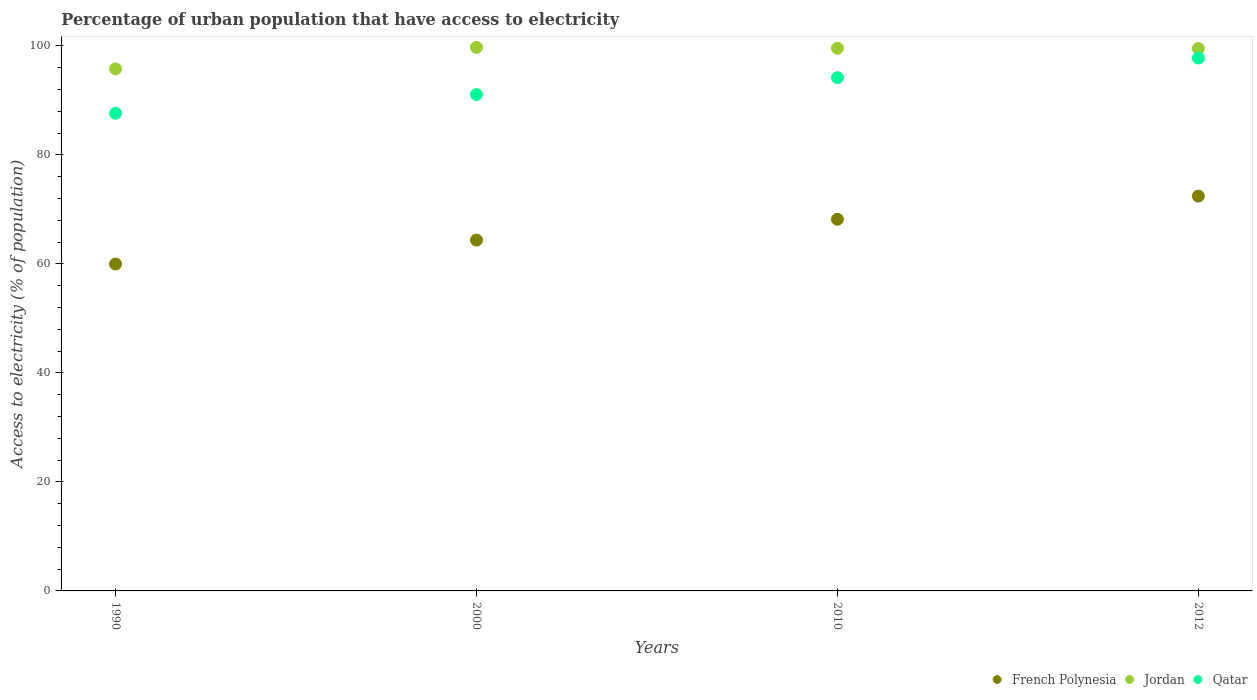Is the number of dotlines equal to the number of legend labels?
Your answer should be compact. Yes. What is the percentage of urban population that have access to electricity in French Polynesia in 1990?
Provide a succinct answer. 59.97. Across all years, what is the maximum percentage of urban population that have access to electricity in Jordan?
Ensure brevity in your answer.  99.7. Across all years, what is the minimum percentage of urban population that have access to electricity in Jordan?
Keep it short and to the point. 95.77. In which year was the percentage of urban population that have access to electricity in French Polynesia maximum?
Your answer should be compact. 2012. What is the total percentage of urban population that have access to electricity in Jordan in the graph?
Provide a short and direct response. 394.52. What is the difference between the percentage of urban population that have access to electricity in French Polynesia in 2000 and that in 2010?
Ensure brevity in your answer.  -3.82. What is the difference between the percentage of urban population that have access to electricity in French Polynesia in 1990 and the percentage of urban population that have access to electricity in Jordan in 2000?
Your answer should be very brief. -39.73. What is the average percentage of urban population that have access to electricity in French Polynesia per year?
Make the answer very short. 66.23. In the year 1990, what is the difference between the percentage of urban population that have access to electricity in French Polynesia and percentage of urban population that have access to electricity in Jordan?
Ensure brevity in your answer.  -35.8. In how many years, is the percentage of urban population that have access to electricity in Qatar greater than 28 %?
Your answer should be compact. 4. What is the ratio of the percentage of urban population that have access to electricity in French Polynesia in 2000 to that in 2012?
Make the answer very short. 0.89. Is the difference between the percentage of urban population that have access to electricity in French Polynesia in 1990 and 2012 greater than the difference between the percentage of urban population that have access to electricity in Jordan in 1990 and 2012?
Offer a very short reply. No. What is the difference between the highest and the second highest percentage of urban population that have access to electricity in Qatar?
Provide a short and direct response. 3.6. What is the difference between the highest and the lowest percentage of urban population that have access to electricity in French Polynesia?
Offer a very short reply. 12.45. In how many years, is the percentage of urban population that have access to electricity in French Polynesia greater than the average percentage of urban population that have access to electricity in French Polynesia taken over all years?
Give a very brief answer. 2. Is the sum of the percentage of urban population that have access to electricity in Qatar in 2000 and 2010 greater than the maximum percentage of urban population that have access to electricity in Jordan across all years?
Offer a terse response. Yes. Does the percentage of urban population that have access to electricity in Jordan monotonically increase over the years?
Your response must be concise. No. How many dotlines are there?
Make the answer very short. 3. How many years are there in the graph?
Your answer should be very brief. 4. Does the graph contain grids?
Make the answer very short. No. How many legend labels are there?
Keep it short and to the point. 3. How are the legend labels stacked?
Your answer should be compact. Horizontal. What is the title of the graph?
Offer a very short reply. Percentage of urban population that have access to electricity. What is the label or title of the Y-axis?
Offer a very short reply. Access to electricity (% of population). What is the Access to electricity (% of population) of French Polynesia in 1990?
Provide a succinct answer. 59.97. What is the Access to electricity (% of population) in Jordan in 1990?
Provide a succinct answer. 95.77. What is the Access to electricity (% of population) in Qatar in 1990?
Give a very brief answer. 87.62. What is the Access to electricity (% of population) in French Polynesia in 2000?
Give a very brief answer. 64.36. What is the Access to electricity (% of population) in Jordan in 2000?
Your response must be concise. 99.7. What is the Access to electricity (% of population) of Qatar in 2000?
Make the answer very short. 91.05. What is the Access to electricity (% of population) in French Polynesia in 2010?
Offer a terse response. 68.18. What is the Access to electricity (% of population) in Jordan in 2010?
Make the answer very short. 99.55. What is the Access to electricity (% of population) of Qatar in 2010?
Keep it short and to the point. 94.15. What is the Access to electricity (% of population) in French Polynesia in 2012?
Your response must be concise. 72.42. What is the Access to electricity (% of population) of Jordan in 2012?
Provide a succinct answer. 99.5. What is the Access to electricity (% of population) of Qatar in 2012?
Provide a succinct answer. 97.75. Across all years, what is the maximum Access to electricity (% of population) of French Polynesia?
Offer a terse response. 72.42. Across all years, what is the maximum Access to electricity (% of population) in Jordan?
Provide a succinct answer. 99.7. Across all years, what is the maximum Access to electricity (% of population) in Qatar?
Your answer should be compact. 97.75. Across all years, what is the minimum Access to electricity (% of population) in French Polynesia?
Keep it short and to the point. 59.97. Across all years, what is the minimum Access to electricity (% of population) in Jordan?
Offer a terse response. 95.77. Across all years, what is the minimum Access to electricity (% of population) of Qatar?
Make the answer very short. 87.62. What is the total Access to electricity (% of population) in French Polynesia in the graph?
Your response must be concise. 264.92. What is the total Access to electricity (% of population) in Jordan in the graph?
Ensure brevity in your answer.  394.52. What is the total Access to electricity (% of population) of Qatar in the graph?
Provide a short and direct response. 370.58. What is the difference between the Access to electricity (% of population) of French Polynesia in 1990 and that in 2000?
Keep it short and to the point. -4.39. What is the difference between the Access to electricity (% of population) of Jordan in 1990 and that in 2000?
Your response must be concise. -3.94. What is the difference between the Access to electricity (% of population) in Qatar in 1990 and that in 2000?
Keep it short and to the point. -3.43. What is the difference between the Access to electricity (% of population) of French Polynesia in 1990 and that in 2010?
Ensure brevity in your answer.  -8.21. What is the difference between the Access to electricity (% of population) of Jordan in 1990 and that in 2010?
Keep it short and to the point. -3.78. What is the difference between the Access to electricity (% of population) in Qatar in 1990 and that in 2010?
Ensure brevity in your answer.  -6.54. What is the difference between the Access to electricity (% of population) of French Polynesia in 1990 and that in 2012?
Ensure brevity in your answer.  -12.45. What is the difference between the Access to electricity (% of population) of Jordan in 1990 and that in 2012?
Keep it short and to the point. -3.73. What is the difference between the Access to electricity (% of population) in Qatar in 1990 and that in 2012?
Provide a short and direct response. -10.13. What is the difference between the Access to electricity (% of population) in French Polynesia in 2000 and that in 2010?
Give a very brief answer. -3.82. What is the difference between the Access to electricity (% of population) in Jordan in 2000 and that in 2010?
Offer a terse response. 0.15. What is the difference between the Access to electricity (% of population) of Qatar in 2000 and that in 2010?
Give a very brief answer. -3.1. What is the difference between the Access to electricity (% of population) of French Polynesia in 2000 and that in 2012?
Keep it short and to the point. -8.06. What is the difference between the Access to electricity (% of population) of Jordan in 2000 and that in 2012?
Provide a short and direct response. 0.2. What is the difference between the Access to electricity (% of population) in Qatar in 2000 and that in 2012?
Offer a very short reply. -6.7. What is the difference between the Access to electricity (% of population) of French Polynesia in 2010 and that in 2012?
Ensure brevity in your answer.  -4.25. What is the difference between the Access to electricity (% of population) in Jordan in 2010 and that in 2012?
Your response must be concise. 0.05. What is the difference between the Access to electricity (% of population) of Qatar in 2010 and that in 2012?
Give a very brief answer. -3.6. What is the difference between the Access to electricity (% of population) of French Polynesia in 1990 and the Access to electricity (% of population) of Jordan in 2000?
Keep it short and to the point. -39.73. What is the difference between the Access to electricity (% of population) in French Polynesia in 1990 and the Access to electricity (% of population) in Qatar in 2000?
Your response must be concise. -31.08. What is the difference between the Access to electricity (% of population) in Jordan in 1990 and the Access to electricity (% of population) in Qatar in 2000?
Provide a short and direct response. 4.72. What is the difference between the Access to electricity (% of population) in French Polynesia in 1990 and the Access to electricity (% of population) in Jordan in 2010?
Your answer should be very brief. -39.58. What is the difference between the Access to electricity (% of population) in French Polynesia in 1990 and the Access to electricity (% of population) in Qatar in 2010?
Give a very brief answer. -34.19. What is the difference between the Access to electricity (% of population) of Jordan in 1990 and the Access to electricity (% of population) of Qatar in 2010?
Your response must be concise. 1.61. What is the difference between the Access to electricity (% of population) in French Polynesia in 1990 and the Access to electricity (% of population) in Jordan in 2012?
Your answer should be compact. -39.53. What is the difference between the Access to electricity (% of population) in French Polynesia in 1990 and the Access to electricity (% of population) in Qatar in 2012?
Your answer should be compact. -37.78. What is the difference between the Access to electricity (% of population) of Jordan in 1990 and the Access to electricity (% of population) of Qatar in 2012?
Offer a very short reply. -1.98. What is the difference between the Access to electricity (% of population) in French Polynesia in 2000 and the Access to electricity (% of population) in Jordan in 2010?
Offer a terse response. -35.19. What is the difference between the Access to electricity (% of population) of French Polynesia in 2000 and the Access to electricity (% of population) of Qatar in 2010?
Your answer should be compact. -29.8. What is the difference between the Access to electricity (% of population) in Jordan in 2000 and the Access to electricity (% of population) in Qatar in 2010?
Keep it short and to the point. 5.55. What is the difference between the Access to electricity (% of population) in French Polynesia in 2000 and the Access to electricity (% of population) in Jordan in 2012?
Your answer should be very brief. -35.14. What is the difference between the Access to electricity (% of population) of French Polynesia in 2000 and the Access to electricity (% of population) of Qatar in 2012?
Your response must be concise. -33.4. What is the difference between the Access to electricity (% of population) in Jordan in 2000 and the Access to electricity (% of population) in Qatar in 2012?
Provide a short and direct response. 1.95. What is the difference between the Access to electricity (% of population) in French Polynesia in 2010 and the Access to electricity (% of population) in Jordan in 2012?
Provide a succinct answer. -31.32. What is the difference between the Access to electricity (% of population) in French Polynesia in 2010 and the Access to electricity (% of population) in Qatar in 2012?
Your answer should be very brief. -29.58. What is the difference between the Access to electricity (% of population) in Jordan in 2010 and the Access to electricity (% of population) in Qatar in 2012?
Offer a very short reply. 1.8. What is the average Access to electricity (% of population) of French Polynesia per year?
Give a very brief answer. 66.23. What is the average Access to electricity (% of population) of Jordan per year?
Provide a short and direct response. 98.63. What is the average Access to electricity (% of population) of Qatar per year?
Ensure brevity in your answer.  92.64. In the year 1990, what is the difference between the Access to electricity (% of population) in French Polynesia and Access to electricity (% of population) in Jordan?
Offer a terse response. -35.8. In the year 1990, what is the difference between the Access to electricity (% of population) in French Polynesia and Access to electricity (% of population) in Qatar?
Provide a succinct answer. -27.65. In the year 1990, what is the difference between the Access to electricity (% of population) of Jordan and Access to electricity (% of population) of Qatar?
Your response must be concise. 8.15. In the year 2000, what is the difference between the Access to electricity (% of population) of French Polynesia and Access to electricity (% of population) of Jordan?
Provide a short and direct response. -35.35. In the year 2000, what is the difference between the Access to electricity (% of population) of French Polynesia and Access to electricity (% of population) of Qatar?
Ensure brevity in your answer.  -26.69. In the year 2000, what is the difference between the Access to electricity (% of population) in Jordan and Access to electricity (% of population) in Qatar?
Make the answer very short. 8.65. In the year 2010, what is the difference between the Access to electricity (% of population) in French Polynesia and Access to electricity (% of population) in Jordan?
Offer a very short reply. -31.37. In the year 2010, what is the difference between the Access to electricity (% of population) of French Polynesia and Access to electricity (% of population) of Qatar?
Give a very brief answer. -25.98. In the year 2010, what is the difference between the Access to electricity (% of population) of Jordan and Access to electricity (% of population) of Qatar?
Keep it short and to the point. 5.39. In the year 2012, what is the difference between the Access to electricity (% of population) in French Polynesia and Access to electricity (% of population) in Jordan?
Provide a short and direct response. -27.08. In the year 2012, what is the difference between the Access to electricity (% of population) in French Polynesia and Access to electricity (% of population) in Qatar?
Your answer should be compact. -25.33. In the year 2012, what is the difference between the Access to electricity (% of population) of Jordan and Access to electricity (% of population) of Qatar?
Your answer should be very brief. 1.75. What is the ratio of the Access to electricity (% of population) of French Polynesia in 1990 to that in 2000?
Make the answer very short. 0.93. What is the ratio of the Access to electricity (% of population) in Jordan in 1990 to that in 2000?
Ensure brevity in your answer.  0.96. What is the ratio of the Access to electricity (% of population) of Qatar in 1990 to that in 2000?
Ensure brevity in your answer.  0.96. What is the ratio of the Access to electricity (% of population) in French Polynesia in 1990 to that in 2010?
Your answer should be very brief. 0.88. What is the ratio of the Access to electricity (% of population) of Qatar in 1990 to that in 2010?
Make the answer very short. 0.93. What is the ratio of the Access to electricity (% of population) in French Polynesia in 1990 to that in 2012?
Offer a very short reply. 0.83. What is the ratio of the Access to electricity (% of population) of Jordan in 1990 to that in 2012?
Offer a very short reply. 0.96. What is the ratio of the Access to electricity (% of population) of Qatar in 1990 to that in 2012?
Offer a very short reply. 0.9. What is the ratio of the Access to electricity (% of population) in French Polynesia in 2000 to that in 2010?
Ensure brevity in your answer.  0.94. What is the ratio of the Access to electricity (% of population) of Jordan in 2000 to that in 2010?
Your answer should be compact. 1. What is the ratio of the Access to electricity (% of population) of Qatar in 2000 to that in 2010?
Your answer should be very brief. 0.97. What is the ratio of the Access to electricity (% of population) in French Polynesia in 2000 to that in 2012?
Your answer should be compact. 0.89. What is the ratio of the Access to electricity (% of population) of Jordan in 2000 to that in 2012?
Keep it short and to the point. 1. What is the ratio of the Access to electricity (% of population) of Qatar in 2000 to that in 2012?
Your response must be concise. 0.93. What is the ratio of the Access to electricity (% of population) of French Polynesia in 2010 to that in 2012?
Give a very brief answer. 0.94. What is the ratio of the Access to electricity (% of population) in Qatar in 2010 to that in 2012?
Provide a short and direct response. 0.96. What is the difference between the highest and the second highest Access to electricity (% of population) in French Polynesia?
Ensure brevity in your answer.  4.25. What is the difference between the highest and the second highest Access to electricity (% of population) in Jordan?
Your answer should be very brief. 0.15. What is the difference between the highest and the second highest Access to electricity (% of population) of Qatar?
Ensure brevity in your answer.  3.6. What is the difference between the highest and the lowest Access to electricity (% of population) in French Polynesia?
Provide a succinct answer. 12.45. What is the difference between the highest and the lowest Access to electricity (% of population) of Jordan?
Offer a terse response. 3.94. What is the difference between the highest and the lowest Access to electricity (% of population) in Qatar?
Provide a short and direct response. 10.13. 